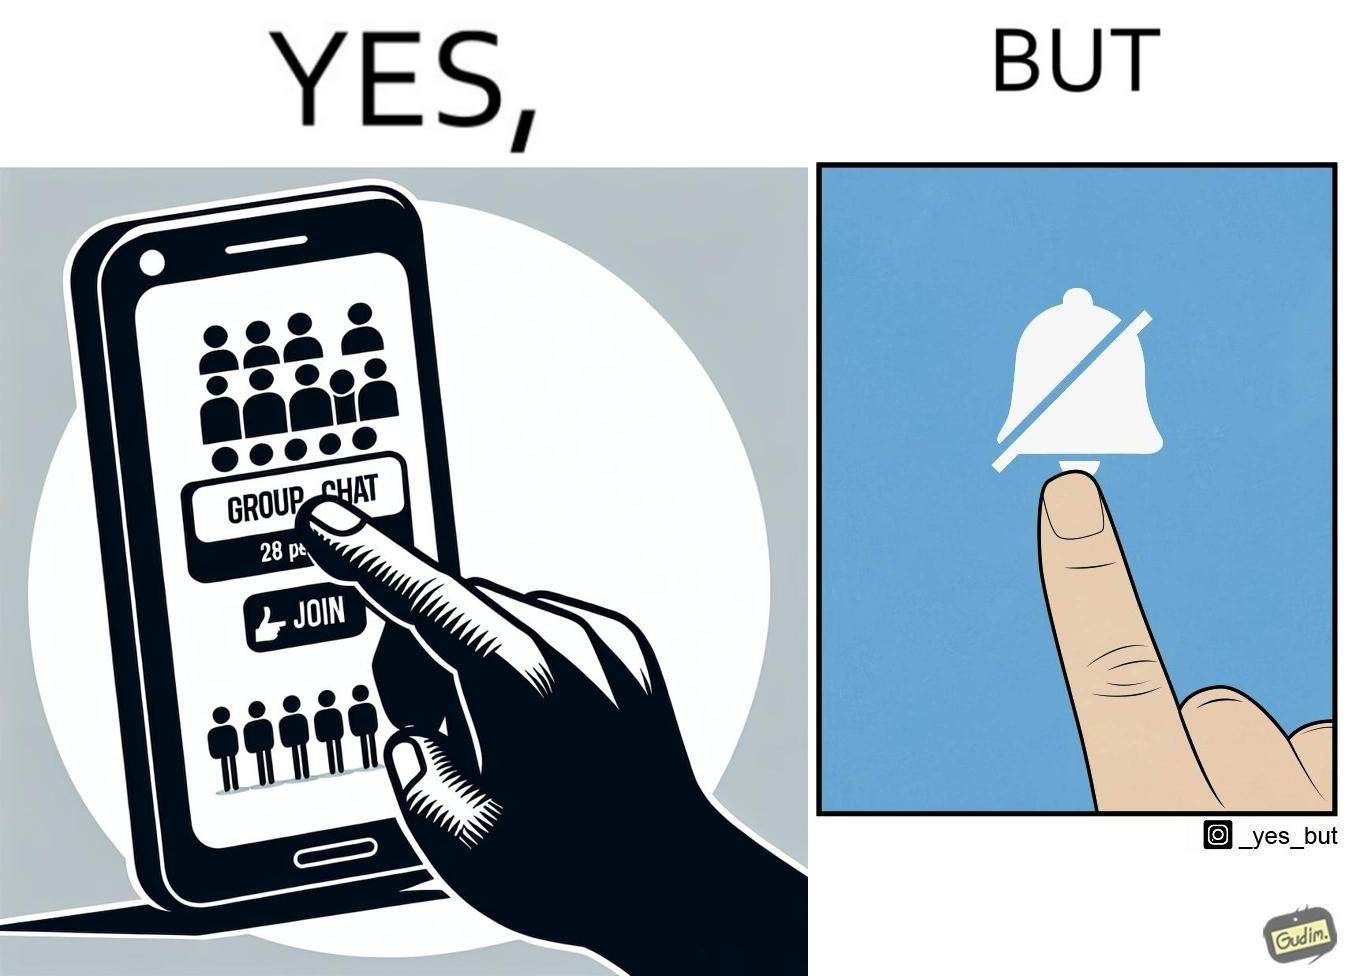What is shown in the left half versus the right half of this image? In the left part of the image: Close-up of phone screen, that has the phrase "Group Chat" on it, and the phrase "28 People" right below it. It  has button labeled "JOIN", and a person's finger is seen clicking the button. In the right part of the image: A touch screen with a "mute notifications" button symbol ( a bell icon that is struck through).  A person's finger is seen clicking the button. 